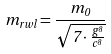Convert formula to latex. <formula><loc_0><loc_0><loc_500><loc_500>m _ { r w l } = \frac { m _ { 0 } } { \sqrt { 7 \cdot \frac { g ^ { 8 } } { c ^ { 8 } } } }</formula> 